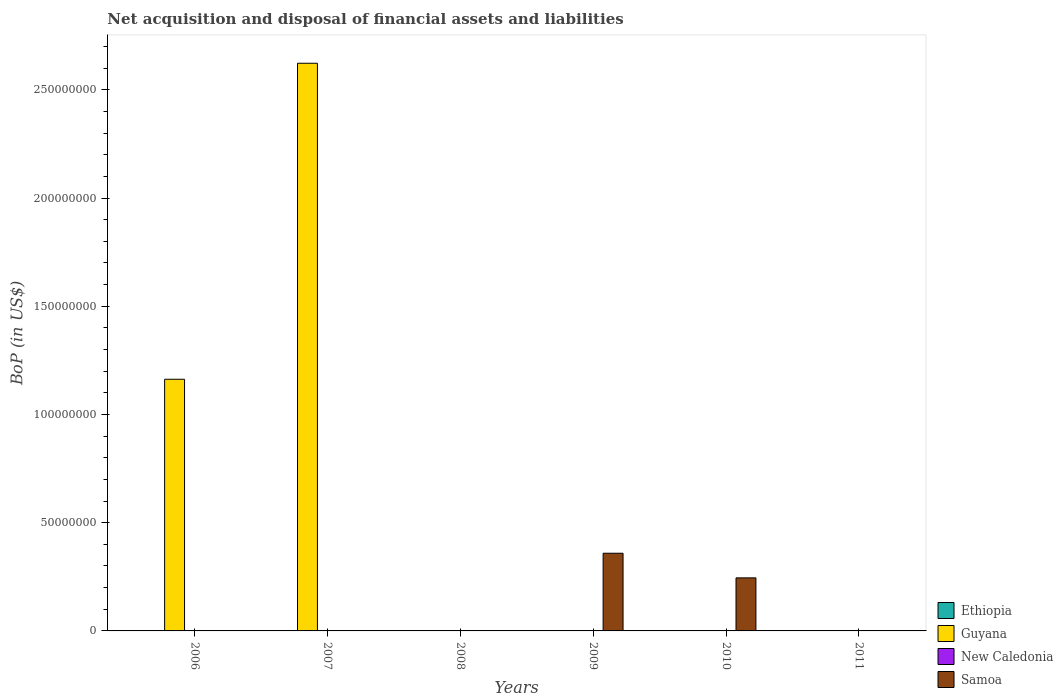Are the number of bars per tick equal to the number of legend labels?
Give a very brief answer. No. What is the Balance of Payments in New Caledonia in 2011?
Your answer should be very brief. 0. Across all years, what is the maximum Balance of Payments in Guyana?
Give a very brief answer. 2.62e+08. Across all years, what is the minimum Balance of Payments in Ethiopia?
Provide a succinct answer. 0. In which year was the Balance of Payments in Samoa maximum?
Ensure brevity in your answer.  2009. What is the total Balance of Payments in New Caledonia in the graph?
Ensure brevity in your answer.  0. What is the difference between the Balance of Payments in Ethiopia in 2011 and the Balance of Payments in Guyana in 2006?
Your response must be concise. -1.16e+08. What is the average Balance of Payments in Samoa per year?
Give a very brief answer. 1.01e+07. In how many years, is the Balance of Payments in Samoa greater than 140000000 US$?
Provide a short and direct response. 0. What is the difference between the highest and the lowest Balance of Payments in Guyana?
Give a very brief answer. 2.62e+08. In how many years, is the Balance of Payments in Ethiopia greater than the average Balance of Payments in Ethiopia taken over all years?
Provide a short and direct response. 0. Are all the bars in the graph horizontal?
Offer a terse response. No. What is the difference between two consecutive major ticks on the Y-axis?
Give a very brief answer. 5.00e+07. Does the graph contain any zero values?
Make the answer very short. Yes. How many legend labels are there?
Provide a succinct answer. 4. How are the legend labels stacked?
Provide a short and direct response. Vertical. What is the title of the graph?
Provide a short and direct response. Net acquisition and disposal of financial assets and liabilities. Does "Haiti" appear as one of the legend labels in the graph?
Keep it short and to the point. No. What is the label or title of the X-axis?
Your answer should be compact. Years. What is the label or title of the Y-axis?
Provide a succinct answer. BoP (in US$). What is the BoP (in US$) of Guyana in 2006?
Keep it short and to the point. 1.16e+08. What is the BoP (in US$) in New Caledonia in 2006?
Ensure brevity in your answer.  0. What is the BoP (in US$) in Samoa in 2006?
Your answer should be compact. 0. What is the BoP (in US$) of Ethiopia in 2007?
Ensure brevity in your answer.  0. What is the BoP (in US$) in Guyana in 2007?
Offer a terse response. 2.62e+08. What is the BoP (in US$) in New Caledonia in 2007?
Offer a very short reply. 0. What is the BoP (in US$) of Guyana in 2008?
Make the answer very short. 0. What is the BoP (in US$) in New Caledonia in 2008?
Make the answer very short. 0. What is the BoP (in US$) of Guyana in 2009?
Offer a terse response. 0. What is the BoP (in US$) of Samoa in 2009?
Give a very brief answer. 3.59e+07. What is the BoP (in US$) of Samoa in 2010?
Make the answer very short. 2.45e+07. What is the BoP (in US$) of Ethiopia in 2011?
Offer a very short reply. 0. What is the BoP (in US$) of Guyana in 2011?
Give a very brief answer. 0. What is the BoP (in US$) in New Caledonia in 2011?
Your answer should be compact. 0. Across all years, what is the maximum BoP (in US$) of Guyana?
Give a very brief answer. 2.62e+08. Across all years, what is the maximum BoP (in US$) in Samoa?
Offer a terse response. 3.59e+07. What is the total BoP (in US$) of Guyana in the graph?
Offer a very short reply. 3.79e+08. What is the total BoP (in US$) in New Caledonia in the graph?
Offer a terse response. 0. What is the total BoP (in US$) in Samoa in the graph?
Offer a terse response. 6.04e+07. What is the difference between the BoP (in US$) in Guyana in 2006 and that in 2007?
Your answer should be compact. -1.46e+08. What is the difference between the BoP (in US$) of Samoa in 2009 and that in 2010?
Offer a terse response. 1.14e+07. What is the difference between the BoP (in US$) in Guyana in 2006 and the BoP (in US$) in Samoa in 2009?
Make the answer very short. 8.04e+07. What is the difference between the BoP (in US$) of Guyana in 2006 and the BoP (in US$) of Samoa in 2010?
Offer a very short reply. 9.18e+07. What is the difference between the BoP (in US$) in Guyana in 2007 and the BoP (in US$) in Samoa in 2009?
Provide a succinct answer. 2.26e+08. What is the difference between the BoP (in US$) of Guyana in 2007 and the BoP (in US$) of Samoa in 2010?
Your answer should be very brief. 2.38e+08. What is the average BoP (in US$) of Guyana per year?
Make the answer very short. 6.31e+07. What is the average BoP (in US$) in Samoa per year?
Keep it short and to the point. 1.01e+07. What is the ratio of the BoP (in US$) of Guyana in 2006 to that in 2007?
Your answer should be very brief. 0.44. What is the ratio of the BoP (in US$) in Samoa in 2009 to that in 2010?
Ensure brevity in your answer.  1.46. What is the difference between the highest and the lowest BoP (in US$) of Guyana?
Give a very brief answer. 2.62e+08. What is the difference between the highest and the lowest BoP (in US$) of Samoa?
Your answer should be very brief. 3.59e+07. 